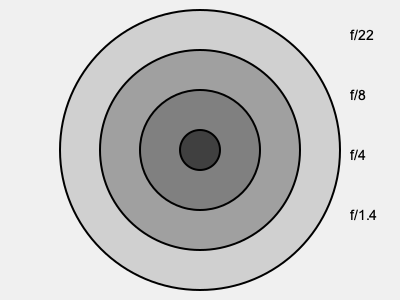As a professional photographer, you know that aperture size affects exposure. Based on the diagram, which aperture setting would you use to achieve the shallowest depth of field while maintaining proper exposure in a low-light situation? To answer this question, let's consider the following steps:

1. Aperture size and f-stop numbers:
   - Larger aperture openings correspond to smaller f-stop numbers.
   - Smaller aperture openings correspond to larger f-stop numbers.

2. Depth of field:
   - Larger apertures (smaller f-stop numbers) create a shallower depth of field.
   - Smaller apertures (larger f-stop numbers) create a deeper depth of field.

3. Light gathering:
   - Larger apertures allow more light to enter the camera.
   - Smaller apertures allow less light to enter the camera.

4. Low-light situations:
   - In low-light conditions, we need to gather more light for proper exposure.

5. Analyzing the options in the diagram:
   - f/22: Smallest aperture, deepest depth of field, least light gathering
   - f/8: Medium-small aperture, moderate depth of field, moderate light gathering
   - f/4: Medium-large aperture, shallow depth of field, good light gathering
   - f/1.4: Largest aperture, shallowest depth of field, best light gathering

6. Conclusion:
   To achieve the shallowest depth of field while maintaining proper exposure in low light, we need the largest aperture (smallest f-stop number) available, which is f/1.4 in this case.
Answer: f/1.4 